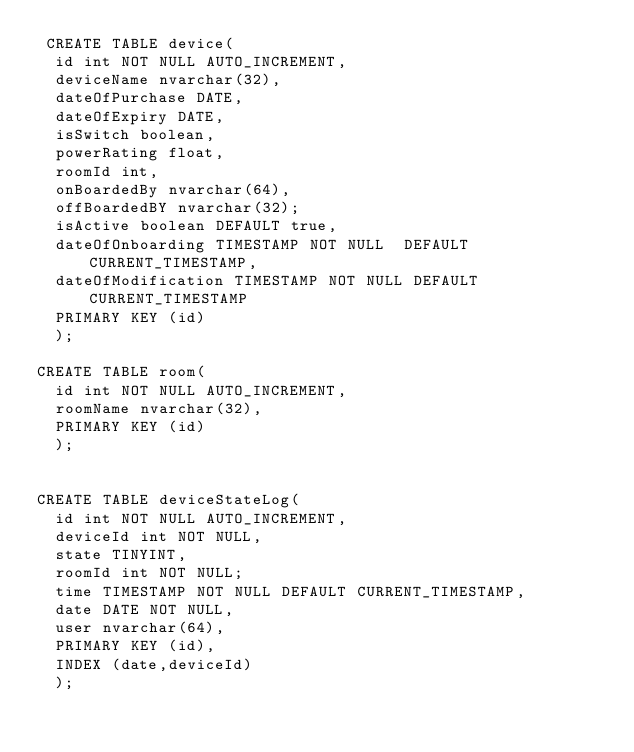<code> <loc_0><loc_0><loc_500><loc_500><_SQL_> CREATE TABLE device(  
  id int NOT NULL AUTO_INCREMENT,
  deviceName nvarchar(32),
  dateOfPurchase DATE,
  dateOfExpiry DATE,
  isSwitch boolean,
  powerRating float,
  roomId int,
  onBoardedBy nvarchar(64),
  offBoardedBY nvarchar(32);
  isActive boolean DEFAULT true,
  dateOfOnboarding TIMESTAMP NOT NULL  DEFAULT CURRENT_TIMESTAMP,
  dateOfModification TIMESTAMP NOT NULL DEFAULT CURRENT_TIMESTAMP
  PRIMARY KEY (id)
  );
  
CREATE TABLE room(
  id int NOT NULL AUTO_INCREMENT,
  roomName nvarchar(32),
  PRIMARY KEY (id)
  );
  
  
CREATE TABLE deviceStateLog(
  id int NOT NULL AUTO_INCREMENT,
  deviceId int NOT NULL,
  state TINYINT,
  roomId int NOT NULL;
  time TIMESTAMP NOT NULL DEFAULT CURRENT_TIMESTAMP,
  date DATE NOT NULL,
  user nvarchar(64),
  PRIMARY KEY (id),
  INDEX (date,deviceId)
  );



</code> 